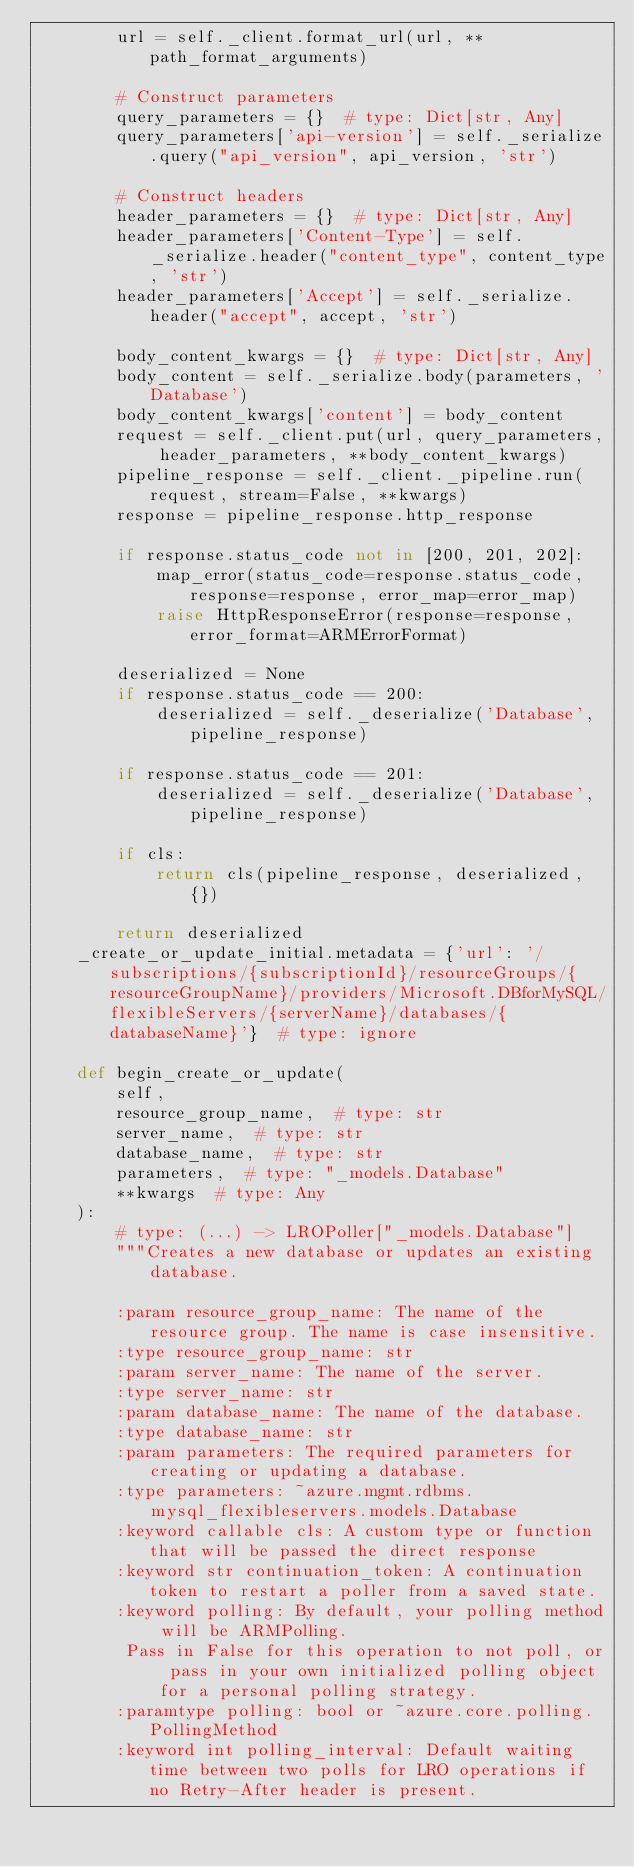Convert code to text. <code><loc_0><loc_0><loc_500><loc_500><_Python_>        url = self._client.format_url(url, **path_format_arguments)

        # Construct parameters
        query_parameters = {}  # type: Dict[str, Any]
        query_parameters['api-version'] = self._serialize.query("api_version", api_version, 'str')

        # Construct headers
        header_parameters = {}  # type: Dict[str, Any]
        header_parameters['Content-Type'] = self._serialize.header("content_type", content_type, 'str')
        header_parameters['Accept'] = self._serialize.header("accept", accept, 'str')

        body_content_kwargs = {}  # type: Dict[str, Any]
        body_content = self._serialize.body(parameters, 'Database')
        body_content_kwargs['content'] = body_content
        request = self._client.put(url, query_parameters, header_parameters, **body_content_kwargs)
        pipeline_response = self._client._pipeline.run(request, stream=False, **kwargs)
        response = pipeline_response.http_response

        if response.status_code not in [200, 201, 202]:
            map_error(status_code=response.status_code, response=response, error_map=error_map)
            raise HttpResponseError(response=response, error_format=ARMErrorFormat)

        deserialized = None
        if response.status_code == 200:
            deserialized = self._deserialize('Database', pipeline_response)

        if response.status_code == 201:
            deserialized = self._deserialize('Database', pipeline_response)

        if cls:
            return cls(pipeline_response, deserialized, {})

        return deserialized
    _create_or_update_initial.metadata = {'url': '/subscriptions/{subscriptionId}/resourceGroups/{resourceGroupName}/providers/Microsoft.DBforMySQL/flexibleServers/{serverName}/databases/{databaseName}'}  # type: ignore

    def begin_create_or_update(
        self,
        resource_group_name,  # type: str
        server_name,  # type: str
        database_name,  # type: str
        parameters,  # type: "_models.Database"
        **kwargs  # type: Any
    ):
        # type: (...) -> LROPoller["_models.Database"]
        """Creates a new database or updates an existing database.

        :param resource_group_name: The name of the resource group. The name is case insensitive.
        :type resource_group_name: str
        :param server_name: The name of the server.
        :type server_name: str
        :param database_name: The name of the database.
        :type database_name: str
        :param parameters: The required parameters for creating or updating a database.
        :type parameters: ~azure.mgmt.rdbms.mysql_flexibleservers.models.Database
        :keyword callable cls: A custom type or function that will be passed the direct response
        :keyword str continuation_token: A continuation token to restart a poller from a saved state.
        :keyword polling: By default, your polling method will be ARMPolling.
         Pass in False for this operation to not poll, or pass in your own initialized polling object for a personal polling strategy.
        :paramtype polling: bool or ~azure.core.polling.PollingMethod
        :keyword int polling_interval: Default waiting time between two polls for LRO operations if no Retry-After header is present.</code> 